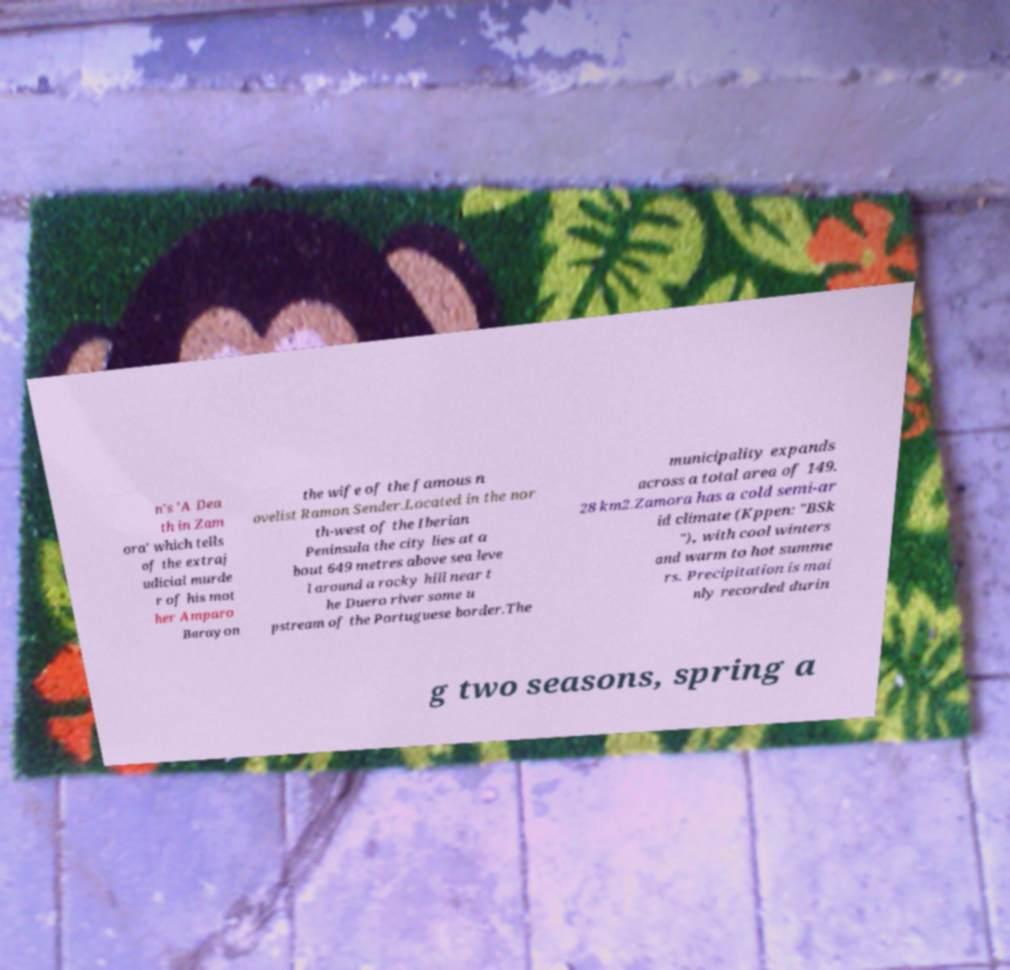There's text embedded in this image that I need extracted. Can you transcribe it verbatim? n's 'A Dea th in Zam ora' which tells of the extraj udicial murde r of his mot her Amparo Barayon the wife of the famous n ovelist Ramon Sender.Located in the nor th-west of the Iberian Peninsula the city lies at a bout 649 metres above sea leve l around a rocky hill near t he Duero river some u pstream of the Portuguese border.The municipality expands across a total area of 149. 28 km2.Zamora has a cold semi-ar id climate (Kppen: "BSk "), with cool winters and warm to hot summe rs. Precipitation is mai nly recorded durin g two seasons, spring a 